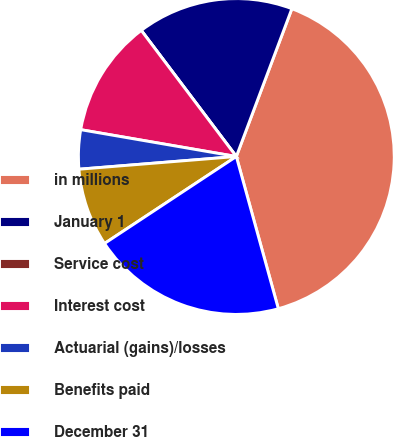Convert chart to OTSL. <chart><loc_0><loc_0><loc_500><loc_500><pie_chart><fcel>in millions<fcel>January 1<fcel>Service cost<fcel>Interest cost<fcel>Actuarial (gains)/losses<fcel>Benefits paid<fcel>December 31<nl><fcel>39.99%<fcel>16.0%<fcel>0.0%<fcel>12.0%<fcel>4.0%<fcel>8.0%<fcel>20.0%<nl></chart> 